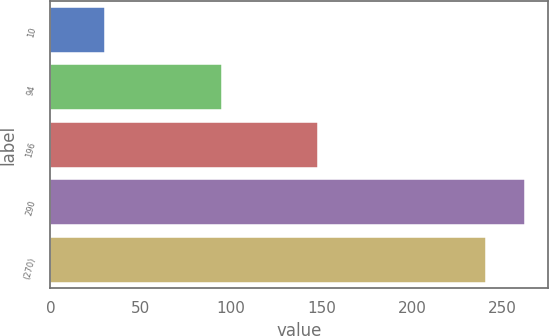<chart> <loc_0><loc_0><loc_500><loc_500><bar_chart><fcel>10<fcel>94<fcel>196<fcel>290<fcel>(270)<nl><fcel>30<fcel>95<fcel>148<fcel>262.4<fcel>241<nl></chart> 